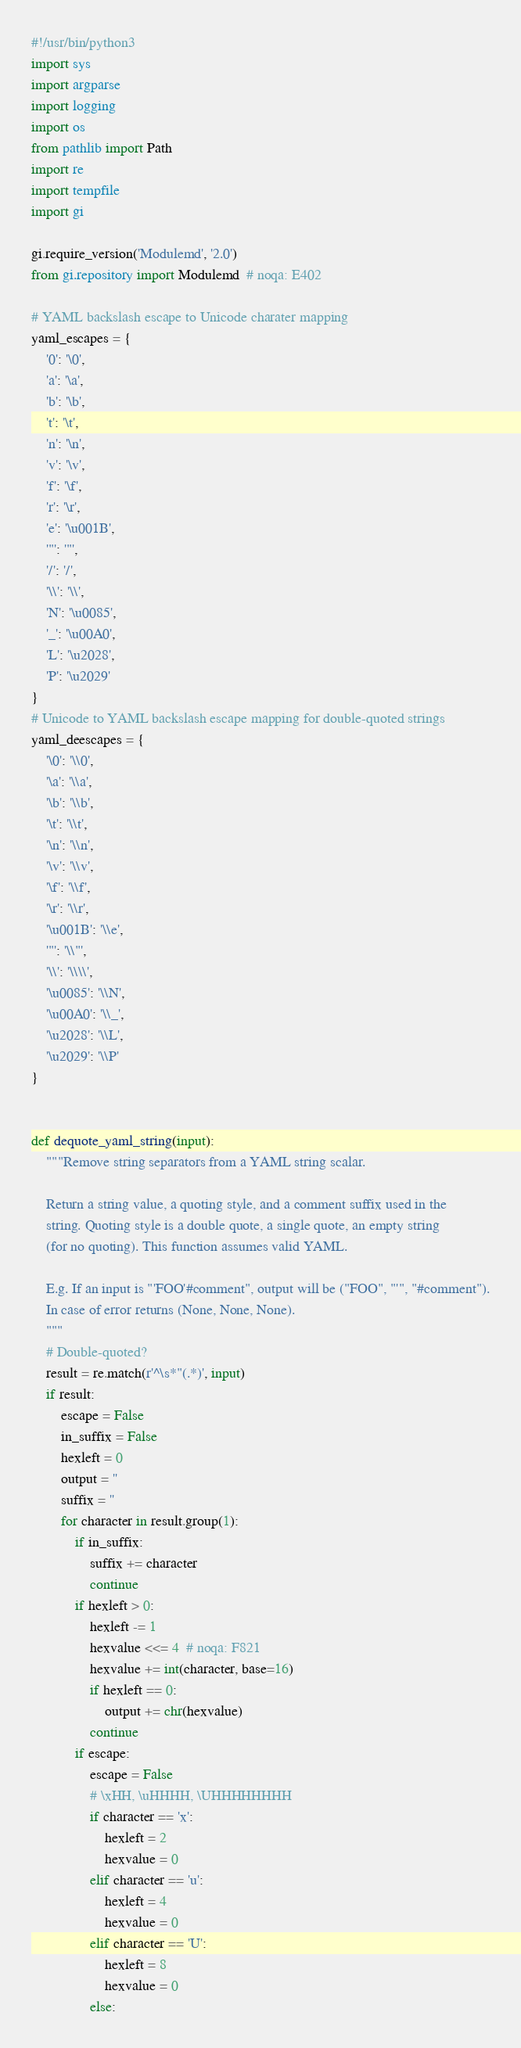Convert code to text. <code><loc_0><loc_0><loc_500><loc_500><_Python_>#!/usr/bin/python3
import sys
import argparse
import logging
import os
from pathlib import Path
import re
import tempfile
import gi

gi.require_version('Modulemd', '2.0')
from gi.repository import Modulemd  # noqa: E402

# YAML backslash escape to Unicode charater mapping
yaml_escapes = {
    '0': '\0',
    'a': '\a',
    'b': '\b',
    't': '\t',
    'n': '\n',
    'v': '\v',
    'f': '\f',
    'r': '\r',
    'e': '\u001B',
    '"': '"',
    '/': '/',
    '\\': '\\',
    'N': '\u0085',
    '_': '\u00A0',
    'L': '\u2028',
    'P': '\u2029'
}
# Unicode to YAML backslash escape mapping for double-quoted strings
yaml_deescapes = {
    '\0': '\\0',
    '\a': '\\a',
    '\b': '\\b',
    '\t': '\\t',
    '\n': '\\n',
    '\v': '\\v',
    '\f': '\\f',
    '\r': '\\r',
    '\u001B': '\\e',
    '"': '\\"',
    '\\': '\\\\',
    '\u0085': '\\N',
    '\u00A0': '\\_',
    '\u2028': '\\L',
    '\u2029': '\\P'
}


def dequote_yaml_string(input):
    """Remove string separators from a YAML string scalar.

    Return a string value, a quoting style, and a comment suffix used in the
    string. Quoting style is a double quote, a single quote, an empty string
    (for no quoting). This function assumes valid YAML.

    E.g. If an input is "'FOO'#comment", output will be ("FOO", "'", "#comment").
    In case of error returns (None, None, None).
    """
    # Double-quoted?
    result = re.match(r'^\s*"(.*)', input)
    if result:
        escape = False
        in_suffix = False
        hexleft = 0
        output = ''
        suffix = ''
        for character in result.group(1):
            if in_suffix:
                suffix += character
                continue
            if hexleft > 0:
                hexleft -= 1
                hexvalue <<= 4  # noqa: F821
                hexvalue += int(character, base=16)
                if hexleft == 0:
                    output += chr(hexvalue)
                continue
            if escape:
                escape = False
                # \xHH, \uHHHH, \UHHHHHHHH
                if character == 'x':
                    hexleft = 2
                    hexvalue = 0
                elif character == 'u':
                    hexleft = 4
                    hexvalue = 0
                elif character == 'U':
                    hexleft = 8
                    hexvalue = 0
                else:</code> 